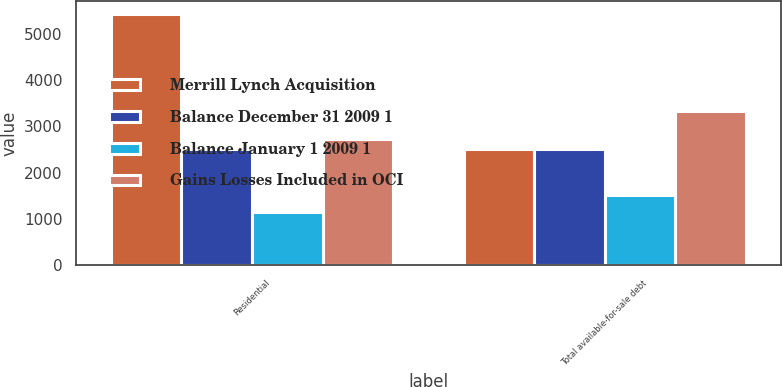<chart> <loc_0><loc_0><loc_500><loc_500><stacked_bar_chart><ecel><fcel>Residential<fcel>Total available-for-sale debt<nl><fcel>Merrill Lynch Acquisition<fcel>5439<fcel>2509<nl><fcel>Balance December 31 2009 1<fcel>2509<fcel>2509<nl><fcel>Balance January 1 2009 1<fcel>1159<fcel>1518<nl><fcel>Gains Losses Included in OCI<fcel>2738<fcel>3327<nl></chart> 